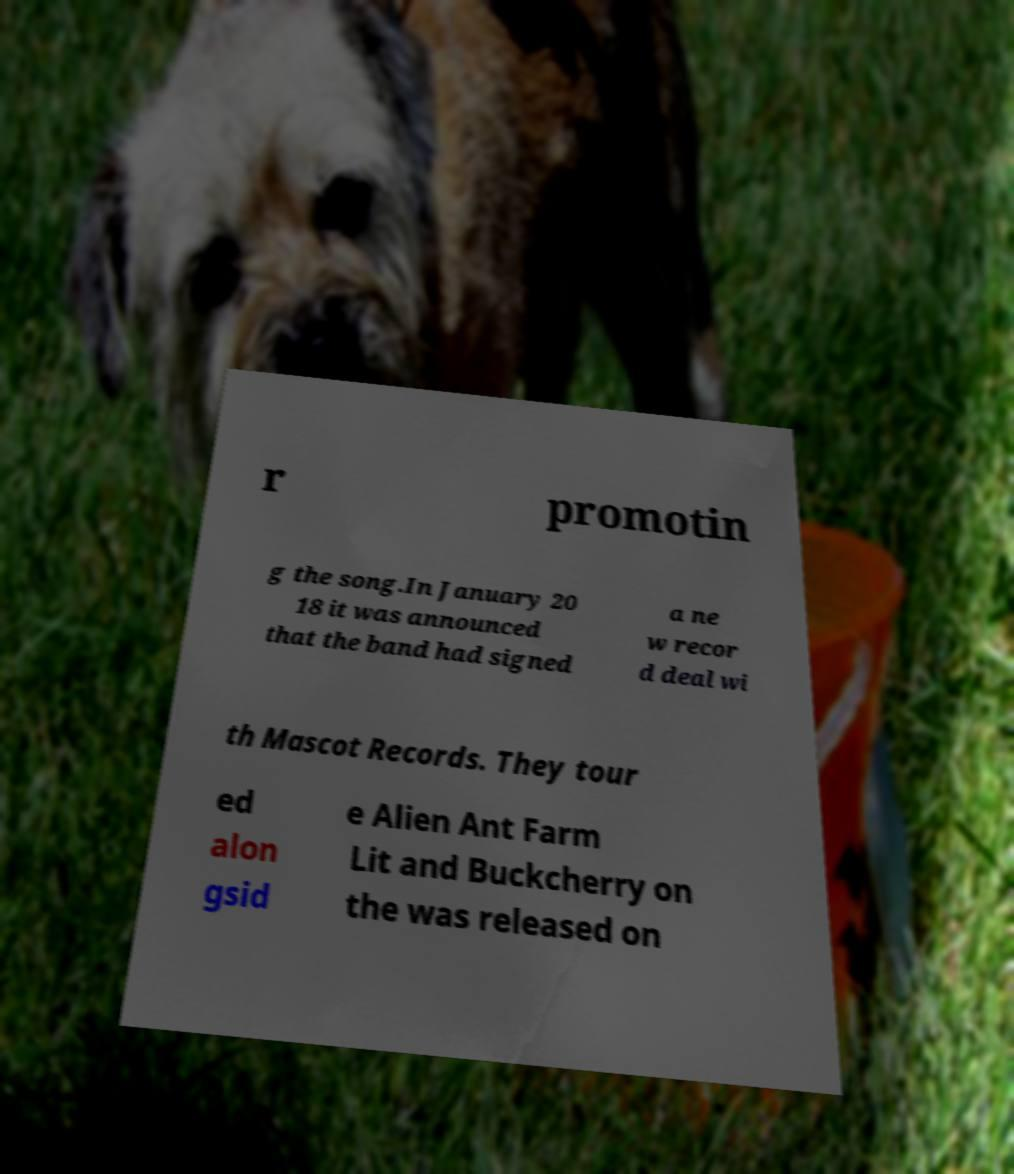Could you extract and type out the text from this image? r promotin g the song.In January 20 18 it was announced that the band had signed a ne w recor d deal wi th Mascot Records. They tour ed alon gsid e Alien Ant Farm Lit and Buckcherry on the was released on 